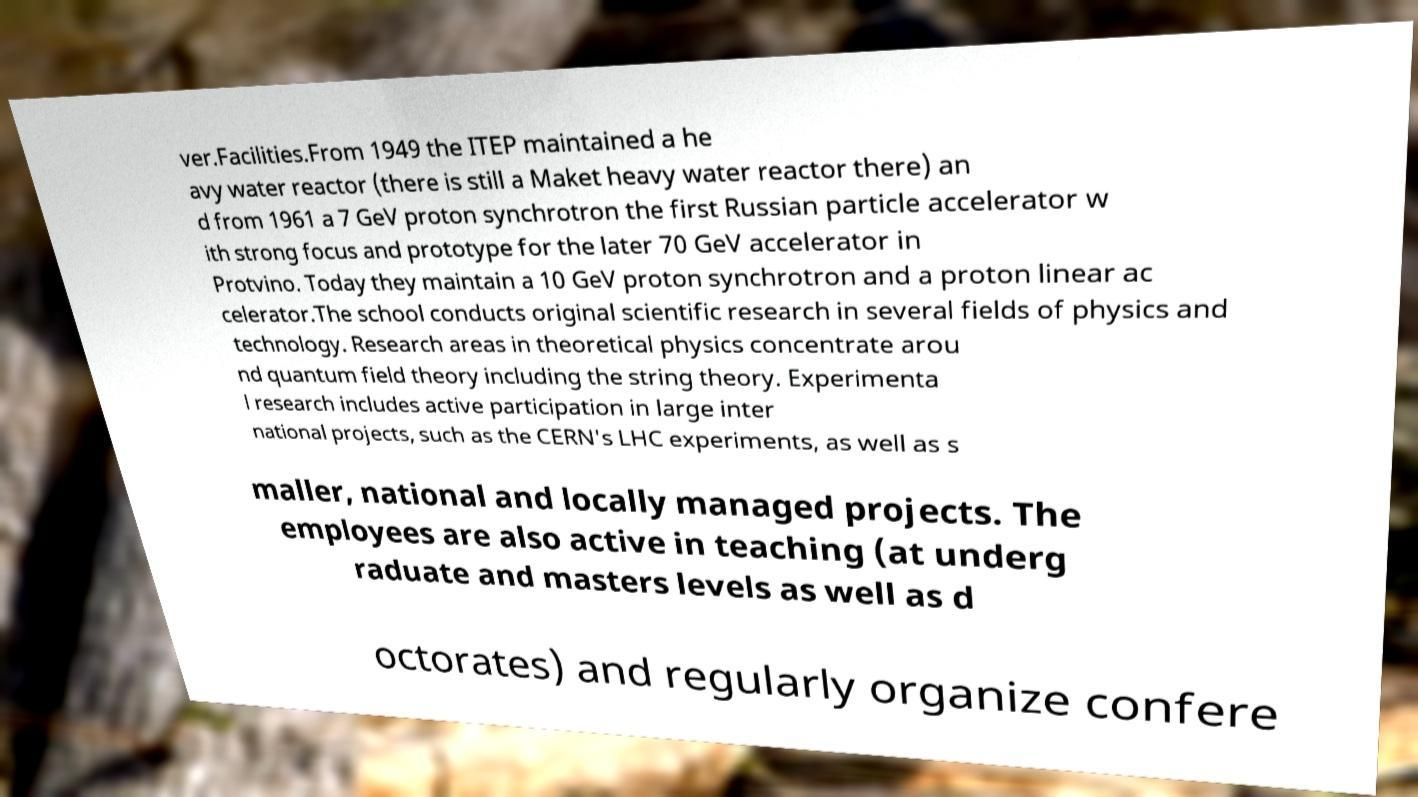Please identify and transcribe the text found in this image. ver.Facilities.From 1949 the ITEP maintained a he avy water reactor (there is still a Maket heavy water reactor there) an d from 1961 a 7 GeV proton synchrotron the first Russian particle accelerator w ith strong focus and prototype for the later 70 GeV accelerator in Protvino. Today they maintain a 10 GeV proton synchrotron and a proton linear ac celerator.The school conducts original scientific research in several fields of physics and technology. Research areas in theoretical physics concentrate arou nd quantum field theory including the string theory. Experimenta l research includes active participation in large inter national projects, such as the CERN's LHC experiments, as well as s maller, national and locally managed projects. The employees are also active in teaching (at underg raduate and masters levels as well as d octorates) and regularly organize confere 